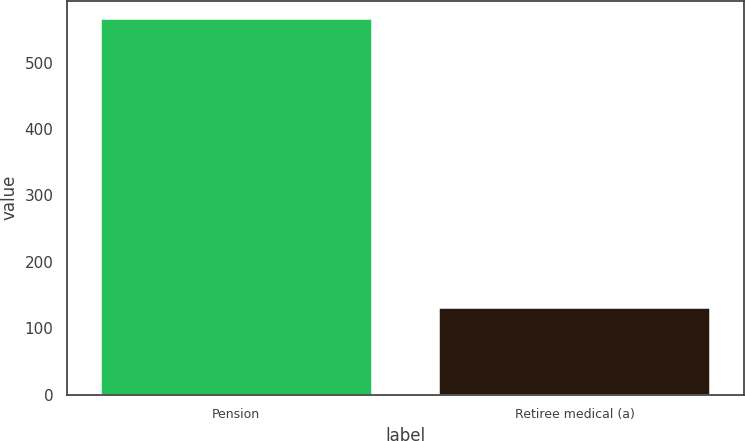<chart> <loc_0><loc_0><loc_500><loc_500><bar_chart><fcel>Pension<fcel>Retiree medical (a)<nl><fcel>565<fcel>130<nl></chart> 